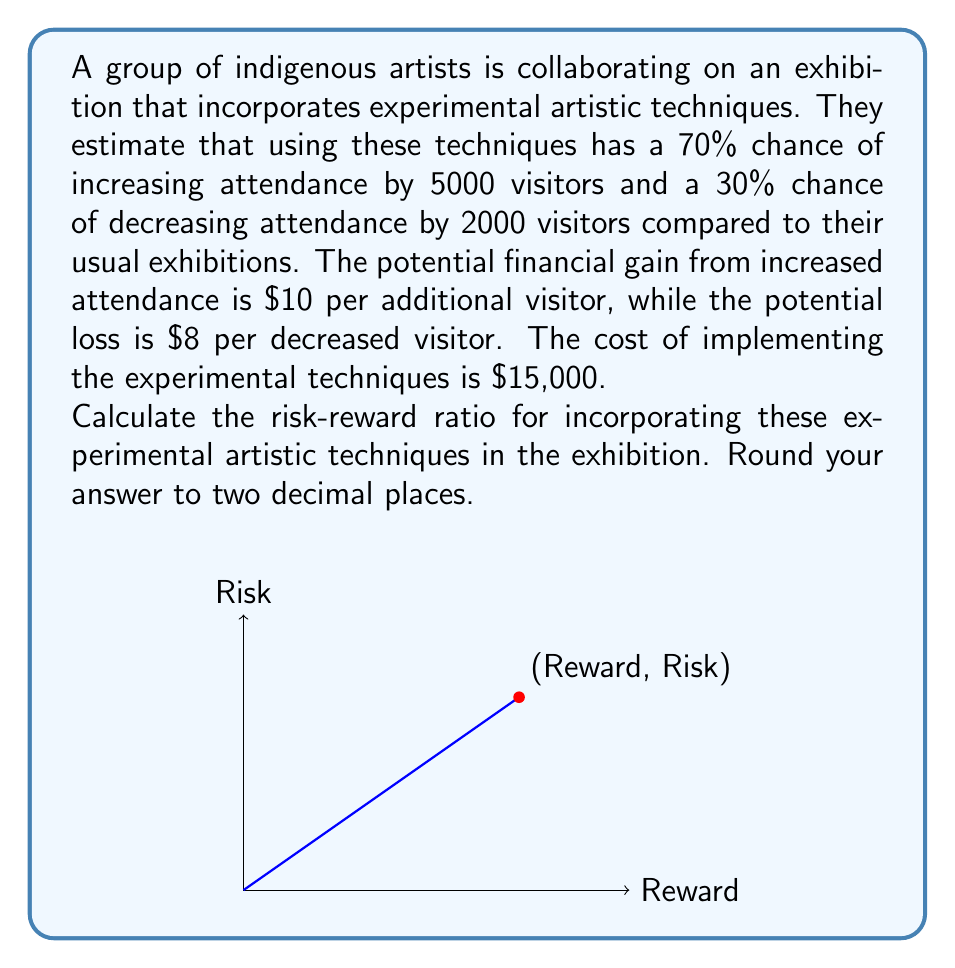What is the answer to this math problem? Let's approach this step-by-step:

1) First, calculate the expected reward:
   - Probability of increase: 70% = 0.7
   - Number of additional visitors: 5000
   - Gain per additional visitor: $10
   Expected Reward = $0.7 \times 5000 \times $10 = $35,000$

2) Next, calculate the expected loss:
   - Probability of decrease: 30% = 0.3
   - Number of decreased visitors: 2000
   - Loss per decreased visitor: $8
   Expected Loss = $0.3 \times 2000 \times $8 = $4,800$

3) The total risk is the sum of the expected loss and the cost of implementation:
   Total Risk = $4,800 + $15,000 = $19,800$

4) The risk-reward ratio is calculated as:
   $$\text{Risk-Reward Ratio} = \frac{\text{Total Risk}}{\text{Expected Reward}}$$

5) Plugging in our values:
   $$\text{Risk-Reward Ratio} = \frac{$19,800}{$35,000} = 0.5657142857$$

6) Rounding to two decimal places:
   $$\text{Risk-Reward Ratio} \approx 0.57$$
Answer: 0.57 